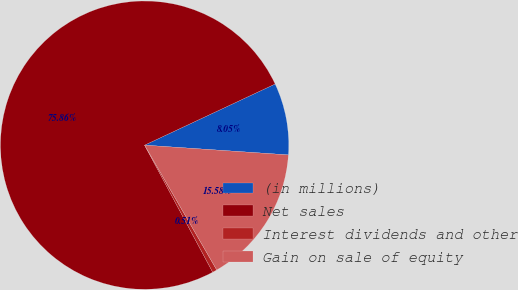<chart> <loc_0><loc_0><loc_500><loc_500><pie_chart><fcel>(in millions)<fcel>Net sales<fcel>Interest dividends and other<fcel>Gain on sale of equity<nl><fcel>8.05%<fcel>75.86%<fcel>0.51%<fcel>15.58%<nl></chart> 